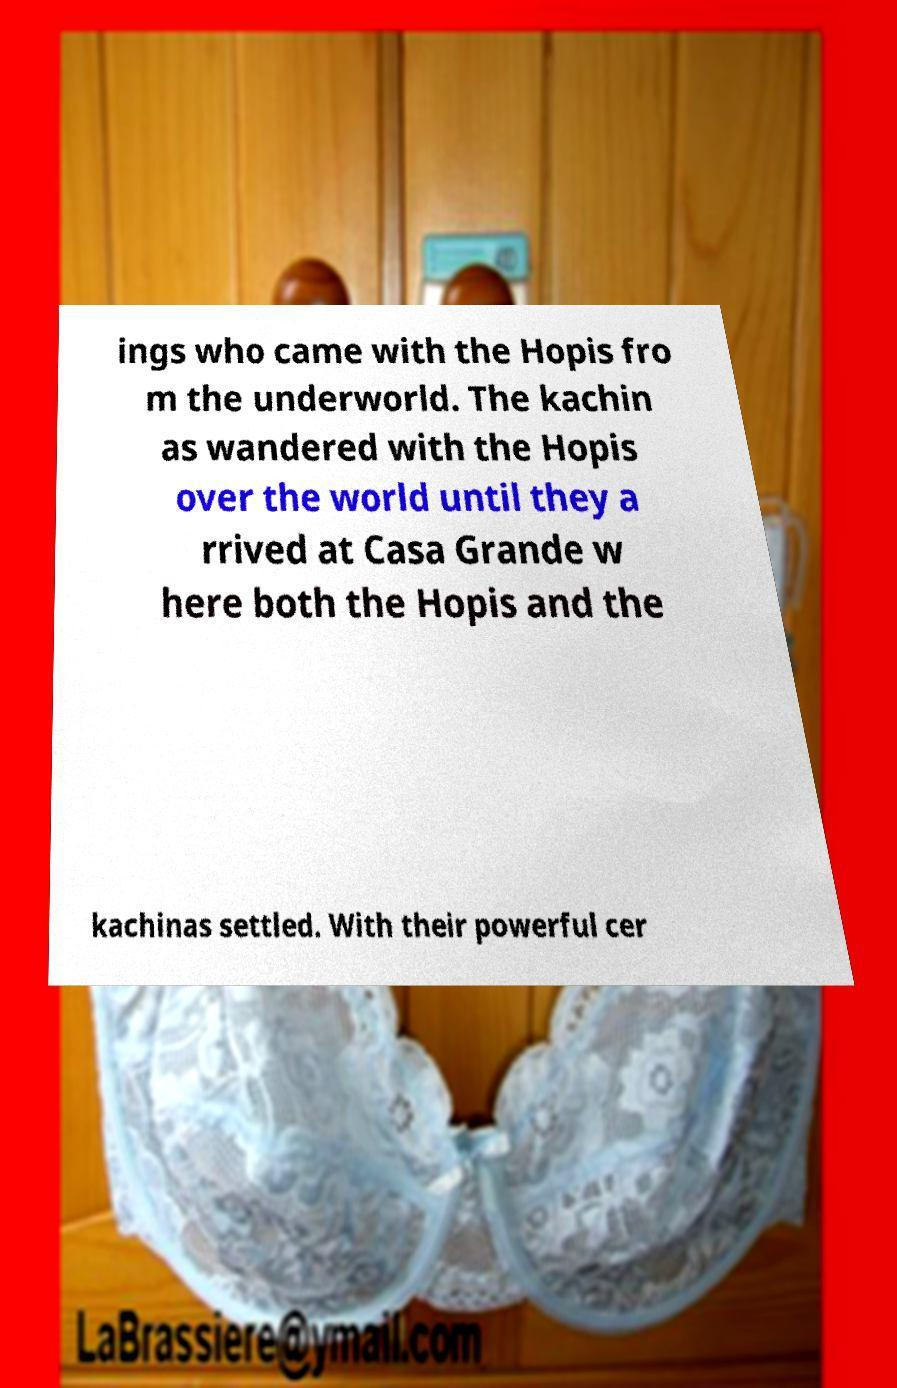Please identify and transcribe the text found in this image. ings who came with the Hopis fro m the underworld. The kachin as wandered with the Hopis over the world until they a rrived at Casa Grande w here both the Hopis and the kachinas settled. With their powerful cer 